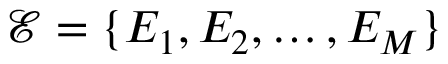<formula> <loc_0><loc_0><loc_500><loc_500>{ \mathcal { E } = \{ E _ { 1 } , E _ { 2 } , \hdots , E _ { M } \} }</formula> 